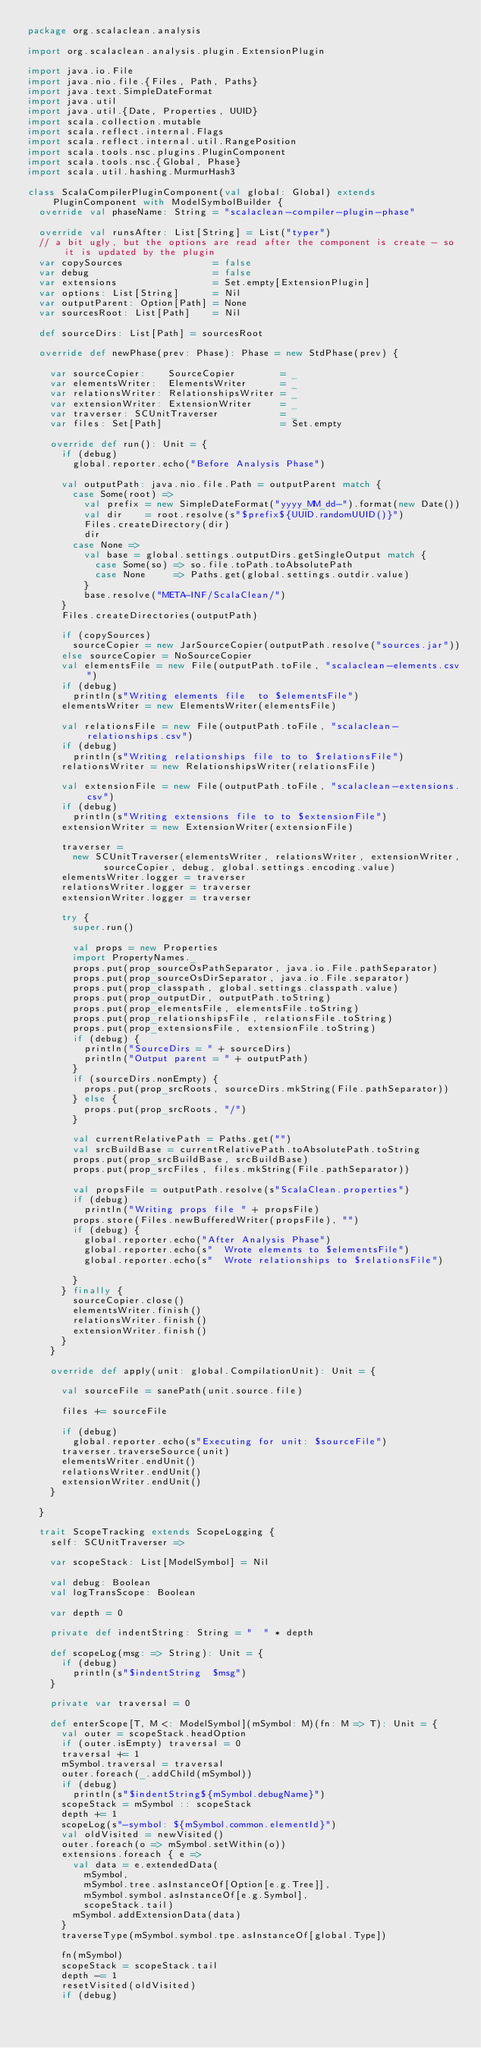<code> <loc_0><loc_0><loc_500><loc_500><_Scala_>package org.scalaclean.analysis

import org.scalaclean.analysis.plugin.ExtensionPlugin

import java.io.File
import java.nio.file.{Files, Path, Paths}
import java.text.SimpleDateFormat
import java.util
import java.util.{Date, Properties, UUID}
import scala.collection.mutable
import scala.reflect.internal.Flags
import scala.reflect.internal.util.RangePosition
import scala.tools.nsc.plugins.PluginComponent
import scala.tools.nsc.{Global, Phase}
import scala.util.hashing.MurmurHash3

class ScalaCompilerPluginComponent(val global: Global) extends PluginComponent with ModelSymbolBuilder {
  override val phaseName: String = "scalaclean-compiler-plugin-phase"

  override val runsAfter: List[String] = List("typer")
  // a bit ugly, but the options are read after the component is create - so it is updated by the plugin
  var copySources                = false
  var debug                      = false
  var extensions                 = Set.empty[ExtensionPlugin]
  var options: List[String]      = Nil
  var outputParent: Option[Path] = None
  var sourcesRoot: List[Path]    = Nil

  def sourceDirs: List[Path] = sourcesRoot

  override def newPhase(prev: Phase): Phase = new StdPhase(prev) {

    var sourceCopier:    SourceCopier        = _
    var elementsWriter:  ElementsWriter      = _
    var relationsWriter: RelationshipsWriter = _
    var extensionWriter: ExtensionWriter     = _
    var traverser: SCUnitTraverser           = _
    var files: Set[Path]                     = Set.empty

    override def run(): Unit = {
      if (debug)
        global.reporter.echo("Before Analysis Phase")

      val outputPath: java.nio.file.Path = outputParent match {
        case Some(root) =>
          val prefix = new SimpleDateFormat("yyyy_MM_dd-").format(new Date())
          val dir    = root.resolve(s"$prefix${UUID.randomUUID()}")
          Files.createDirectory(dir)
          dir
        case None =>
          val base = global.settings.outputDirs.getSingleOutput match {
            case Some(so) => so.file.toPath.toAbsolutePath
            case None     => Paths.get(global.settings.outdir.value)
          }
          base.resolve("META-INF/ScalaClean/")
      }
      Files.createDirectories(outputPath)

      if (copySources)
        sourceCopier = new JarSourceCopier(outputPath.resolve("sources.jar"))
      else sourceCopier = NoSourceCopier
      val elementsFile = new File(outputPath.toFile, "scalaclean-elements.csv")
      if (debug)
        println(s"Writing elements file  to $elementsFile")
      elementsWriter = new ElementsWriter(elementsFile)

      val relationsFile = new File(outputPath.toFile, "scalaclean-relationships.csv")
      if (debug)
        println(s"Writing relationships file to to $relationsFile")
      relationsWriter = new RelationshipsWriter(relationsFile)

      val extensionFile = new File(outputPath.toFile, "scalaclean-extensions.csv")
      if (debug)
        println(s"Writing extensions file to to $extensionFile")
      extensionWriter = new ExtensionWriter(extensionFile)

      traverser =
        new SCUnitTraverser(elementsWriter, relationsWriter, extensionWriter, sourceCopier, debug, global.settings.encoding.value)
      elementsWriter.logger = traverser
      relationsWriter.logger = traverser
      extensionWriter.logger = traverser

      try {
        super.run()

        val props = new Properties
        import PropertyNames._
        props.put(prop_sourceOsPathSeparator, java.io.File.pathSeparator)
        props.put(prop_sourceOsDirSeparator, java.io.File.separator)
        props.put(prop_classpath, global.settings.classpath.value)
        props.put(prop_outputDir, outputPath.toString)
        props.put(prop_elementsFile, elementsFile.toString)
        props.put(prop_relationshipsFile, relationsFile.toString)
        props.put(prop_extensionsFile, extensionFile.toString)
        if (debug) {
          println("SourceDirs = " + sourceDirs)
          println("Output parent = " + outputPath)
        }
        if (sourceDirs.nonEmpty) {
          props.put(prop_srcRoots, sourceDirs.mkString(File.pathSeparator))
        } else {
          props.put(prop_srcRoots, "/")
        }

        val currentRelativePath = Paths.get("")
        val srcBuildBase = currentRelativePath.toAbsolutePath.toString
        props.put(prop_srcBuildBase, srcBuildBase)
        props.put(prop_srcFiles, files.mkString(File.pathSeparator))

        val propsFile = outputPath.resolve(s"ScalaClean.properties")
        if (debug)
          println("Writing props file " + propsFile)
        props.store(Files.newBufferedWriter(propsFile), "")
        if (debug) {
          global.reporter.echo("After Analysis Phase")
          global.reporter.echo(s"  Wrote elements to $elementsFile")
          global.reporter.echo(s"  Wrote relationships to $relationsFile")

        }
      } finally {
        sourceCopier.close()
        elementsWriter.finish()
        relationsWriter.finish()
        extensionWriter.finish()
      }
    }

    override def apply(unit: global.CompilationUnit): Unit = {

      val sourceFile = sanePath(unit.source.file)

      files += sourceFile

      if (debug)
        global.reporter.echo(s"Executing for unit: $sourceFile")
      traverser.traverseSource(unit)
      elementsWriter.endUnit()
      relationsWriter.endUnit()
      extensionWriter.endUnit()
    }

  }

  trait ScopeTracking extends ScopeLogging {
    self: SCUnitTraverser =>

    var scopeStack: List[ModelSymbol] = Nil

    val debug: Boolean
    val logTransScope: Boolean

    var depth = 0

    private def indentString: String = "  " * depth

    def scopeLog(msg: => String): Unit = {
      if (debug)
        println(s"$indentString  $msg")
    }

    private var traversal = 0

    def enterScope[T, M <: ModelSymbol](mSymbol: M)(fn: M => T): Unit = {
      val outer = scopeStack.headOption
      if (outer.isEmpty) traversal = 0
      traversal += 1
      mSymbol.traversal = traversal
      outer.foreach(_.addChild(mSymbol))
      if (debug)
        println(s"$indentString${mSymbol.debugName}")
      scopeStack = mSymbol :: scopeStack
      depth += 1
      scopeLog(s"-symbol: ${mSymbol.common.elementId}")
      val oldVisited = newVisited()
      outer.foreach(o => mSymbol.setWithin(o))
      extensions.foreach { e =>
        val data = e.extendedData(
          mSymbol,
          mSymbol.tree.asInstanceOf[Option[e.g.Tree]],
          mSymbol.symbol.asInstanceOf[e.g.Symbol],
          scopeStack.tail)
        mSymbol.addExtensionData(data)
      }
      traverseType(mSymbol.symbol.tpe.asInstanceOf[global.Type])

      fn(mSymbol)
      scopeStack = scopeStack.tail
      depth -= 1
      resetVisited(oldVisited)
      if (debug)</code> 